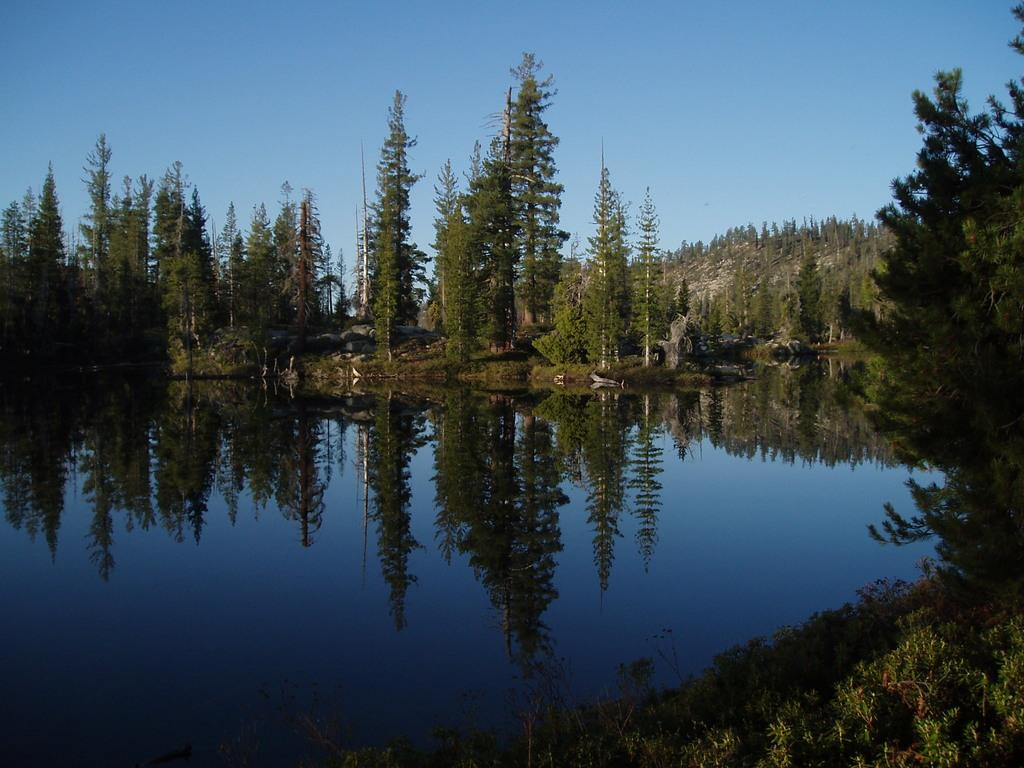What is one of the main elements in the image? There is water in the image. What other natural elements can be seen in the image? There are plants and trees in the image. What is the relationship between the trees and the water in the image? The reflection of trees is visible on the water. What can be seen in the background of the image? There is sky visible in the background of the image. What type of pin is holding the match on the tray in the image? There is no pin, match, or tray present in the image. 